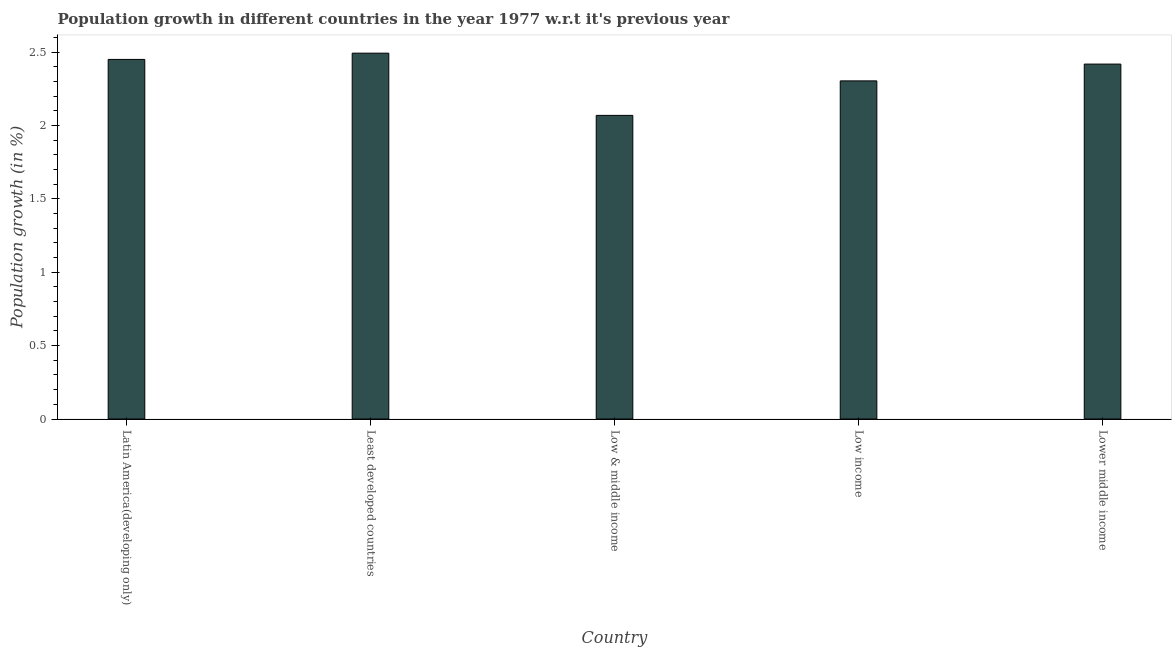Does the graph contain any zero values?
Offer a very short reply. No. What is the title of the graph?
Your response must be concise. Population growth in different countries in the year 1977 w.r.t it's previous year. What is the label or title of the Y-axis?
Provide a succinct answer. Population growth (in %). What is the population growth in Low & middle income?
Your answer should be very brief. 2.07. Across all countries, what is the maximum population growth?
Your answer should be compact. 2.49. Across all countries, what is the minimum population growth?
Provide a succinct answer. 2.07. In which country was the population growth maximum?
Offer a terse response. Least developed countries. In which country was the population growth minimum?
Make the answer very short. Low & middle income. What is the sum of the population growth?
Provide a succinct answer. 11.74. What is the difference between the population growth in Low & middle income and Low income?
Your answer should be very brief. -0.23. What is the average population growth per country?
Keep it short and to the point. 2.35. What is the median population growth?
Make the answer very short. 2.42. In how many countries, is the population growth greater than 1.7 %?
Make the answer very short. 5. What is the ratio of the population growth in Latin America(developing only) to that in Low & middle income?
Give a very brief answer. 1.18. Is the population growth in Latin America(developing only) less than that in Least developed countries?
Your answer should be compact. Yes. What is the difference between the highest and the second highest population growth?
Give a very brief answer. 0.04. Is the sum of the population growth in Latin America(developing only) and Low income greater than the maximum population growth across all countries?
Your response must be concise. Yes. What is the difference between the highest and the lowest population growth?
Your answer should be compact. 0.42. In how many countries, is the population growth greater than the average population growth taken over all countries?
Offer a terse response. 3. How many countries are there in the graph?
Your answer should be compact. 5. What is the difference between two consecutive major ticks on the Y-axis?
Make the answer very short. 0.5. Are the values on the major ticks of Y-axis written in scientific E-notation?
Keep it short and to the point. No. What is the Population growth (in %) of Latin America(developing only)?
Provide a succinct answer. 2.45. What is the Population growth (in %) of Least developed countries?
Your answer should be very brief. 2.49. What is the Population growth (in %) of Low & middle income?
Provide a short and direct response. 2.07. What is the Population growth (in %) of Low income?
Offer a terse response. 2.3. What is the Population growth (in %) of Lower middle income?
Offer a terse response. 2.42. What is the difference between the Population growth (in %) in Latin America(developing only) and Least developed countries?
Your response must be concise. -0.04. What is the difference between the Population growth (in %) in Latin America(developing only) and Low & middle income?
Ensure brevity in your answer.  0.38. What is the difference between the Population growth (in %) in Latin America(developing only) and Low income?
Provide a short and direct response. 0.15. What is the difference between the Population growth (in %) in Latin America(developing only) and Lower middle income?
Make the answer very short. 0.03. What is the difference between the Population growth (in %) in Least developed countries and Low & middle income?
Your answer should be compact. 0.42. What is the difference between the Population growth (in %) in Least developed countries and Low income?
Your response must be concise. 0.19. What is the difference between the Population growth (in %) in Least developed countries and Lower middle income?
Ensure brevity in your answer.  0.07. What is the difference between the Population growth (in %) in Low & middle income and Low income?
Ensure brevity in your answer.  -0.24. What is the difference between the Population growth (in %) in Low & middle income and Lower middle income?
Provide a short and direct response. -0.35. What is the difference between the Population growth (in %) in Low income and Lower middle income?
Offer a terse response. -0.11. What is the ratio of the Population growth (in %) in Latin America(developing only) to that in Least developed countries?
Your answer should be very brief. 0.98. What is the ratio of the Population growth (in %) in Latin America(developing only) to that in Low & middle income?
Keep it short and to the point. 1.18. What is the ratio of the Population growth (in %) in Latin America(developing only) to that in Low income?
Your answer should be compact. 1.06. What is the ratio of the Population growth (in %) in Least developed countries to that in Low & middle income?
Give a very brief answer. 1.21. What is the ratio of the Population growth (in %) in Least developed countries to that in Low income?
Your answer should be compact. 1.08. What is the ratio of the Population growth (in %) in Least developed countries to that in Lower middle income?
Give a very brief answer. 1.03. What is the ratio of the Population growth (in %) in Low & middle income to that in Low income?
Your answer should be very brief. 0.9. What is the ratio of the Population growth (in %) in Low & middle income to that in Lower middle income?
Provide a succinct answer. 0.85. What is the ratio of the Population growth (in %) in Low income to that in Lower middle income?
Offer a very short reply. 0.95. 